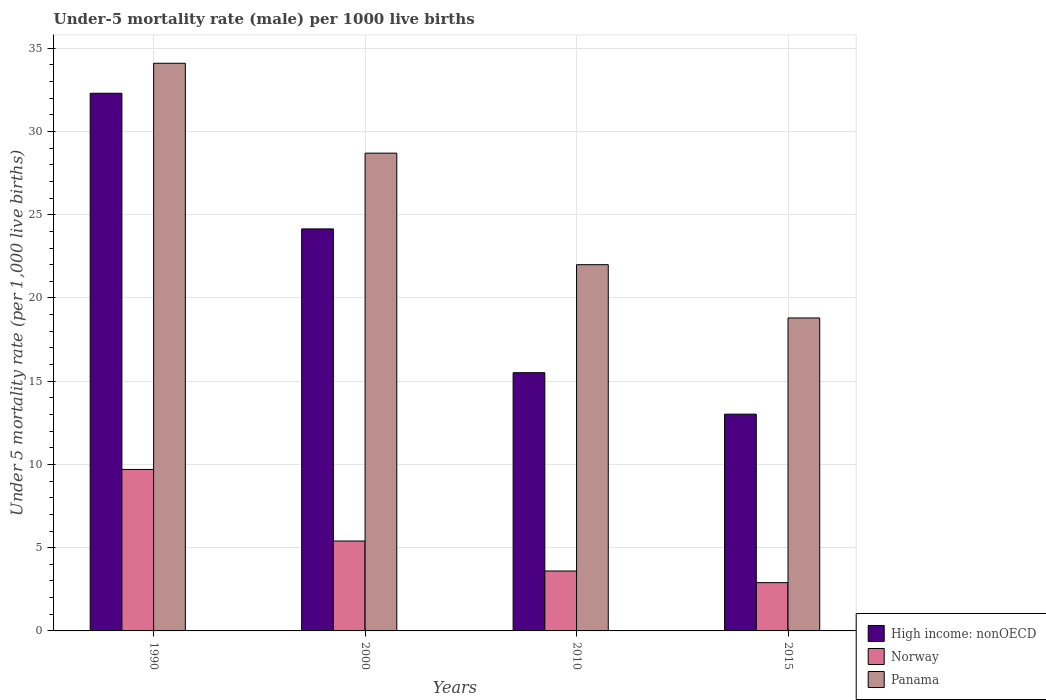Are the number of bars per tick equal to the number of legend labels?
Give a very brief answer. Yes. Are the number of bars on each tick of the X-axis equal?
Offer a terse response. Yes. How many bars are there on the 2nd tick from the left?
Ensure brevity in your answer.  3. In how many cases, is the number of bars for a given year not equal to the number of legend labels?
Keep it short and to the point. 0. What is the under-five mortality rate in Norway in 2010?
Your response must be concise. 3.6. Across all years, what is the maximum under-five mortality rate in High income: nonOECD?
Your response must be concise. 32.3. Across all years, what is the minimum under-five mortality rate in High income: nonOECD?
Your answer should be very brief. 13.02. In which year was the under-five mortality rate in High income: nonOECD minimum?
Offer a very short reply. 2015. What is the total under-five mortality rate in Panama in the graph?
Your answer should be very brief. 103.6. What is the difference between the under-five mortality rate in Norway in 2000 and that in 2010?
Provide a short and direct response. 1.8. What is the difference between the under-five mortality rate in High income: nonOECD in 2000 and the under-five mortality rate in Norway in 1990?
Provide a short and direct response. 14.45. What is the average under-five mortality rate in High income: nonOECD per year?
Make the answer very short. 21.24. In the year 2015, what is the difference between the under-five mortality rate in High income: nonOECD and under-five mortality rate in Norway?
Offer a very short reply. 10.12. In how many years, is the under-five mortality rate in Panama greater than 8?
Your answer should be compact. 4. What is the ratio of the under-five mortality rate in Norway in 1990 to that in 2000?
Your response must be concise. 1.8. What is the difference between the highest and the second highest under-five mortality rate in Panama?
Give a very brief answer. 5.4. What is the difference between the highest and the lowest under-five mortality rate in Norway?
Provide a short and direct response. 6.8. Is the sum of the under-five mortality rate in Panama in 2000 and 2010 greater than the maximum under-five mortality rate in High income: nonOECD across all years?
Give a very brief answer. Yes. What does the 3rd bar from the left in 1990 represents?
Offer a terse response. Panama. What does the 3rd bar from the right in 2000 represents?
Your answer should be compact. High income: nonOECD. Are all the bars in the graph horizontal?
Your answer should be compact. No. How many years are there in the graph?
Provide a succinct answer. 4. What is the difference between two consecutive major ticks on the Y-axis?
Provide a short and direct response. 5. Are the values on the major ticks of Y-axis written in scientific E-notation?
Keep it short and to the point. No. Does the graph contain grids?
Offer a very short reply. Yes. Where does the legend appear in the graph?
Your response must be concise. Bottom right. What is the title of the graph?
Keep it short and to the point. Under-5 mortality rate (male) per 1000 live births. Does "China" appear as one of the legend labels in the graph?
Your response must be concise. No. What is the label or title of the X-axis?
Your answer should be compact. Years. What is the label or title of the Y-axis?
Your answer should be very brief. Under 5 mortality rate (per 1,0 live births). What is the Under 5 mortality rate (per 1,000 live births) in High income: nonOECD in 1990?
Offer a very short reply. 32.3. What is the Under 5 mortality rate (per 1,000 live births) in Panama in 1990?
Your answer should be compact. 34.1. What is the Under 5 mortality rate (per 1,000 live births) of High income: nonOECD in 2000?
Give a very brief answer. 24.15. What is the Under 5 mortality rate (per 1,000 live births) in Panama in 2000?
Provide a succinct answer. 28.7. What is the Under 5 mortality rate (per 1,000 live births) in High income: nonOECD in 2010?
Offer a terse response. 15.51. What is the Under 5 mortality rate (per 1,000 live births) of Panama in 2010?
Keep it short and to the point. 22. What is the Under 5 mortality rate (per 1,000 live births) in High income: nonOECD in 2015?
Ensure brevity in your answer.  13.02. What is the Under 5 mortality rate (per 1,000 live births) of Norway in 2015?
Offer a terse response. 2.9. Across all years, what is the maximum Under 5 mortality rate (per 1,000 live births) in High income: nonOECD?
Give a very brief answer. 32.3. Across all years, what is the maximum Under 5 mortality rate (per 1,000 live births) of Panama?
Offer a terse response. 34.1. Across all years, what is the minimum Under 5 mortality rate (per 1,000 live births) of High income: nonOECD?
Your answer should be very brief. 13.02. Across all years, what is the minimum Under 5 mortality rate (per 1,000 live births) in Panama?
Keep it short and to the point. 18.8. What is the total Under 5 mortality rate (per 1,000 live births) in High income: nonOECD in the graph?
Your response must be concise. 84.98. What is the total Under 5 mortality rate (per 1,000 live births) in Norway in the graph?
Offer a very short reply. 21.6. What is the total Under 5 mortality rate (per 1,000 live births) of Panama in the graph?
Ensure brevity in your answer.  103.6. What is the difference between the Under 5 mortality rate (per 1,000 live births) of High income: nonOECD in 1990 and that in 2000?
Ensure brevity in your answer.  8.15. What is the difference between the Under 5 mortality rate (per 1,000 live births) in Norway in 1990 and that in 2000?
Your answer should be very brief. 4.3. What is the difference between the Under 5 mortality rate (per 1,000 live births) in Panama in 1990 and that in 2000?
Offer a very short reply. 5.4. What is the difference between the Under 5 mortality rate (per 1,000 live births) in High income: nonOECD in 1990 and that in 2010?
Your response must be concise. 16.79. What is the difference between the Under 5 mortality rate (per 1,000 live births) in Norway in 1990 and that in 2010?
Ensure brevity in your answer.  6.1. What is the difference between the Under 5 mortality rate (per 1,000 live births) in Panama in 1990 and that in 2010?
Your answer should be compact. 12.1. What is the difference between the Under 5 mortality rate (per 1,000 live births) of High income: nonOECD in 1990 and that in 2015?
Provide a succinct answer. 19.28. What is the difference between the Under 5 mortality rate (per 1,000 live births) of Norway in 1990 and that in 2015?
Give a very brief answer. 6.8. What is the difference between the Under 5 mortality rate (per 1,000 live births) in Panama in 1990 and that in 2015?
Make the answer very short. 15.3. What is the difference between the Under 5 mortality rate (per 1,000 live births) of High income: nonOECD in 2000 and that in 2010?
Give a very brief answer. 8.64. What is the difference between the Under 5 mortality rate (per 1,000 live births) of Panama in 2000 and that in 2010?
Keep it short and to the point. 6.7. What is the difference between the Under 5 mortality rate (per 1,000 live births) in High income: nonOECD in 2000 and that in 2015?
Offer a terse response. 11.13. What is the difference between the Under 5 mortality rate (per 1,000 live births) of Norway in 2000 and that in 2015?
Provide a succinct answer. 2.5. What is the difference between the Under 5 mortality rate (per 1,000 live births) of Panama in 2000 and that in 2015?
Make the answer very short. 9.9. What is the difference between the Under 5 mortality rate (per 1,000 live births) in High income: nonOECD in 2010 and that in 2015?
Provide a succinct answer. 2.49. What is the difference between the Under 5 mortality rate (per 1,000 live births) in Panama in 2010 and that in 2015?
Make the answer very short. 3.2. What is the difference between the Under 5 mortality rate (per 1,000 live births) in High income: nonOECD in 1990 and the Under 5 mortality rate (per 1,000 live births) in Norway in 2000?
Provide a succinct answer. 26.9. What is the difference between the Under 5 mortality rate (per 1,000 live births) of High income: nonOECD in 1990 and the Under 5 mortality rate (per 1,000 live births) of Panama in 2000?
Make the answer very short. 3.6. What is the difference between the Under 5 mortality rate (per 1,000 live births) in Norway in 1990 and the Under 5 mortality rate (per 1,000 live births) in Panama in 2000?
Provide a short and direct response. -19. What is the difference between the Under 5 mortality rate (per 1,000 live births) of High income: nonOECD in 1990 and the Under 5 mortality rate (per 1,000 live births) of Norway in 2010?
Give a very brief answer. 28.7. What is the difference between the Under 5 mortality rate (per 1,000 live births) in High income: nonOECD in 1990 and the Under 5 mortality rate (per 1,000 live births) in Panama in 2010?
Ensure brevity in your answer.  10.3. What is the difference between the Under 5 mortality rate (per 1,000 live births) in High income: nonOECD in 1990 and the Under 5 mortality rate (per 1,000 live births) in Norway in 2015?
Your response must be concise. 29.4. What is the difference between the Under 5 mortality rate (per 1,000 live births) of High income: nonOECD in 1990 and the Under 5 mortality rate (per 1,000 live births) of Panama in 2015?
Offer a terse response. 13.5. What is the difference between the Under 5 mortality rate (per 1,000 live births) of High income: nonOECD in 2000 and the Under 5 mortality rate (per 1,000 live births) of Norway in 2010?
Provide a short and direct response. 20.55. What is the difference between the Under 5 mortality rate (per 1,000 live births) in High income: nonOECD in 2000 and the Under 5 mortality rate (per 1,000 live births) in Panama in 2010?
Your response must be concise. 2.15. What is the difference between the Under 5 mortality rate (per 1,000 live births) of Norway in 2000 and the Under 5 mortality rate (per 1,000 live births) of Panama in 2010?
Your response must be concise. -16.6. What is the difference between the Under 5 mortality rate (per 1,000 live births) in High income: nonOECD in 2000 and the Under 5 mortality rate (per 1,000 live births) in Norway in 2015?
Ensure brevity in your answer.  21.25. What is the difference between the Under 5 mortality rate (per 1,000 live births) of High income: nonOECD in 2000 and the Under 5 mortality rate (per 1,000 live births) of Panama in 2015?
Keep it short and to the point. 5.35. What is the difference between the Under 5 mortality rate (per 1,000 live births) in High income: nonOECD in 2010 and the Under 5 mortality rate (per 1,000 live births) in Norway in 2015?
Provide a succinct answer. 12.61. What is the difference between the Under 5 mortality rate (per 1,000 live births) of High income: nonOECD in 2010 and the Under 5 mortality rate (per 1,000 live births) of Panama in 2015?
Your answer should be compact. -3.29. What is the difference between the Under 5 mortality rate (per 1,000 live births) of Norway in 2010 and the Under 5 mortality rate (per 1,000 live births) of Panama in 2015?
Offer a terse response. -15.2. What is the average Under 5 mortality rate (per 1,000 live births) of High income: nonOECD per year?
Your answer should be very brief. 21.25. What is the average Under 5 mortality rate (per 1,000 live births) of Panama per year?
Provide a succinct answer. 25.9. In the year 1990, what is the difference between the Under 5 mortality rate (per 1,000 live births) of High income: nonOECD and Under 5 mortality rate (per 1,000 live births) of Norway?
Your answer should be very brief. 22.6. In the year 1990, what is the difference between the Under 5 mortality rate (per 1,000 live births) of High income: nonOECD and Under 5 mortality rate (per 1,000 live births) of Panama?
Give a very brief answer. -1.8. In the year 1990, what is the difference between the Under 5 mortality rate (per 1,000 live births) in Norway and Under 5 mortality rate (per 1,000 live births) in Panama?
Offer a very short reply. -24.4. In the year 2000, what is the difference between the Under 5 mortality rate (per 1,000 live births) in High income: nonOECD and Under 5 mortality rate (per 1,000 live births) in Norway?
Your answer should be compact. 18.75. In the year 2000, what is the difference between the Under 5 mortality rate (per 1,000 live births) of High income: nonOECD and Under 5 mortality rate (per 1,000 live births) of Panama?
Give a very brief answer. -4.55. In the year 2000, what is the difference between the Under 5 mortality rate (per 1,000 live births) of Norway and Under 5 mortality rate (per 1,000 live births) of Panama?
Provide a short and direct response. -23.3. In the year 2010, what is the difference between the Under 5 mortality rate (per 1,000 live births) of High income: nonOECD and Under 5 mortality rate (per 1,000 live births) of Norway?
Keep it short and to the point. 11.91. In the year 2010, what is the difference between the Under 5 mortality rate (per 1,000 live births) in High income: nonOECD and Under 5 mortality rate (per 1,000 live births) in Panama?
Keep it short and to the point. -6.49. In the year 2010, what is the difference between the Under 5 mortality rate (per 1,000 live births) of Norway and Under 5 mortality rate (per 1,000 live births) of Panama?
Your answer should be very brief. -18.4. In the year 2015, what is the difference between the Under 5 mortality rate (per 1,000 live births) of High income: nonOECD and Under 5 mortality rate (per 1,000 live births) of Norway?
Provide a short and direct response. 10.12. In the year 2015, what is the difference between the Under 5 mortality rate (per 1,000 live births) in High income: nonOECD and Under 5 mortality rate (per 1,000 live births) in Panama?
Keep it short and to the point. -5.78. In the year 2015, what is the difference between the Under 5 mortality rate (per 1,000 live births) in Norway and Under 5 mortality rate (per 1,000 live births) in Panama?
Ensure brevity in your answer.  -15.9. What is the ratio of the Under 5 mortality rate (per 1,000 live births) in High income: nonOECD in 1990 to that in 2000?
Your answer should be very brief. 1.34. What is the ratio of the Under 5 mortality rate (per 1,000 live births) of Norway in 1990 to that in 2000?
Keep it short and to the point. 1.8. What is the ratio of the Under 5 mortality rate (per 1,000 live births) of Panama in 1990 to that in 2000?
Give a very brief answer. 1.19. What is the ratio of the Under 5 mortality rate (per 1,000 live births) of High income: nonOECD in 1990 to that in 2010?
Offer a terse response. 2.08. What is the ratio of the Under 5 mortality rate (per 1,000 live births) in Norway in 1990 to that in 2010?
Your answer should be very brief. 2.69. What is the ratio of the Under 5 mortality rate (per 1,000 live births) in Panama in 1990 to that in 2010?
Offer a terse response. 1.55. What is the ratio of the Under 5 mortality rate (per 1,000 live births) of High income: nonOECD in 1990 to that in 2015?
Your answer should be very brief. 2.48. What is the ratio of the Under 5 mortality rate (per 1,000 live births) in Norway in 1990 to that in 2015?
Offer a terse response. 3.34. What is the ratio of the Under 5 mortality rate (per 1,000 live births) of Panama in 1990 to that in 2015?
Provide a succinct answer. 1.81. What is the ratio of the Under 5 mortality rate (per 1,000 live births) in High income: nonOECD in 2000 to that in 2010?
Make the answer very short. 1.56. What is the ratio of the Under 5 mortality rate (per 1,000 live births) of Panama in 2000 to that in 2010?
Make the answer very short. 1.3. What is the ratio of the Under 5 mortality rate (per 1,000 live births) of High income: nonOECD in 2000 to that in 2015?
Your answer should be compact. 1.85. What is the ratio of the Under 5 mortality rate (per 1,000 live births) of Norway in 2000 to that in 2015?
Offer a very short reply. 1.86. What is the ratio of the Under 5 mortality rate (per 1,000 live births) of Panama in 2000 to that in 2015?
Keep it short and to the point. 1.53. What is the ratio of the Under 5 mortality rate (per 1,000 live births) of High income: nonOECD in 2010 to that in 2015?
Your response must be concise. 1.19. What is the ratio of the Under 5 mortality rate (per 1,000 live births) of Norway in 2010 to that in 2015?
Provide a succinct answer. 1.24. What is the ratio of the Under 5 mortality rate (per 1,000 live births) of Panama in 2010 to that in 2015?
Give a very brief answer. 1.17. What is the difference between the highest and the second highest Under 5 mortality rate (per 1,000 live births) in High income: nonOECD?
Keep it short and to the point. 8.15. What is the difference between the highest and the lowest Under 5 mortality rate (per 1,000 live births) of High income: nonOECD?
Provide a short and direct response. 19.28. What is the difference between the highest and the lowest Under 5 mortality rate (per 1,000 live births) in Norway?
Your response must be concise. 6.8. 